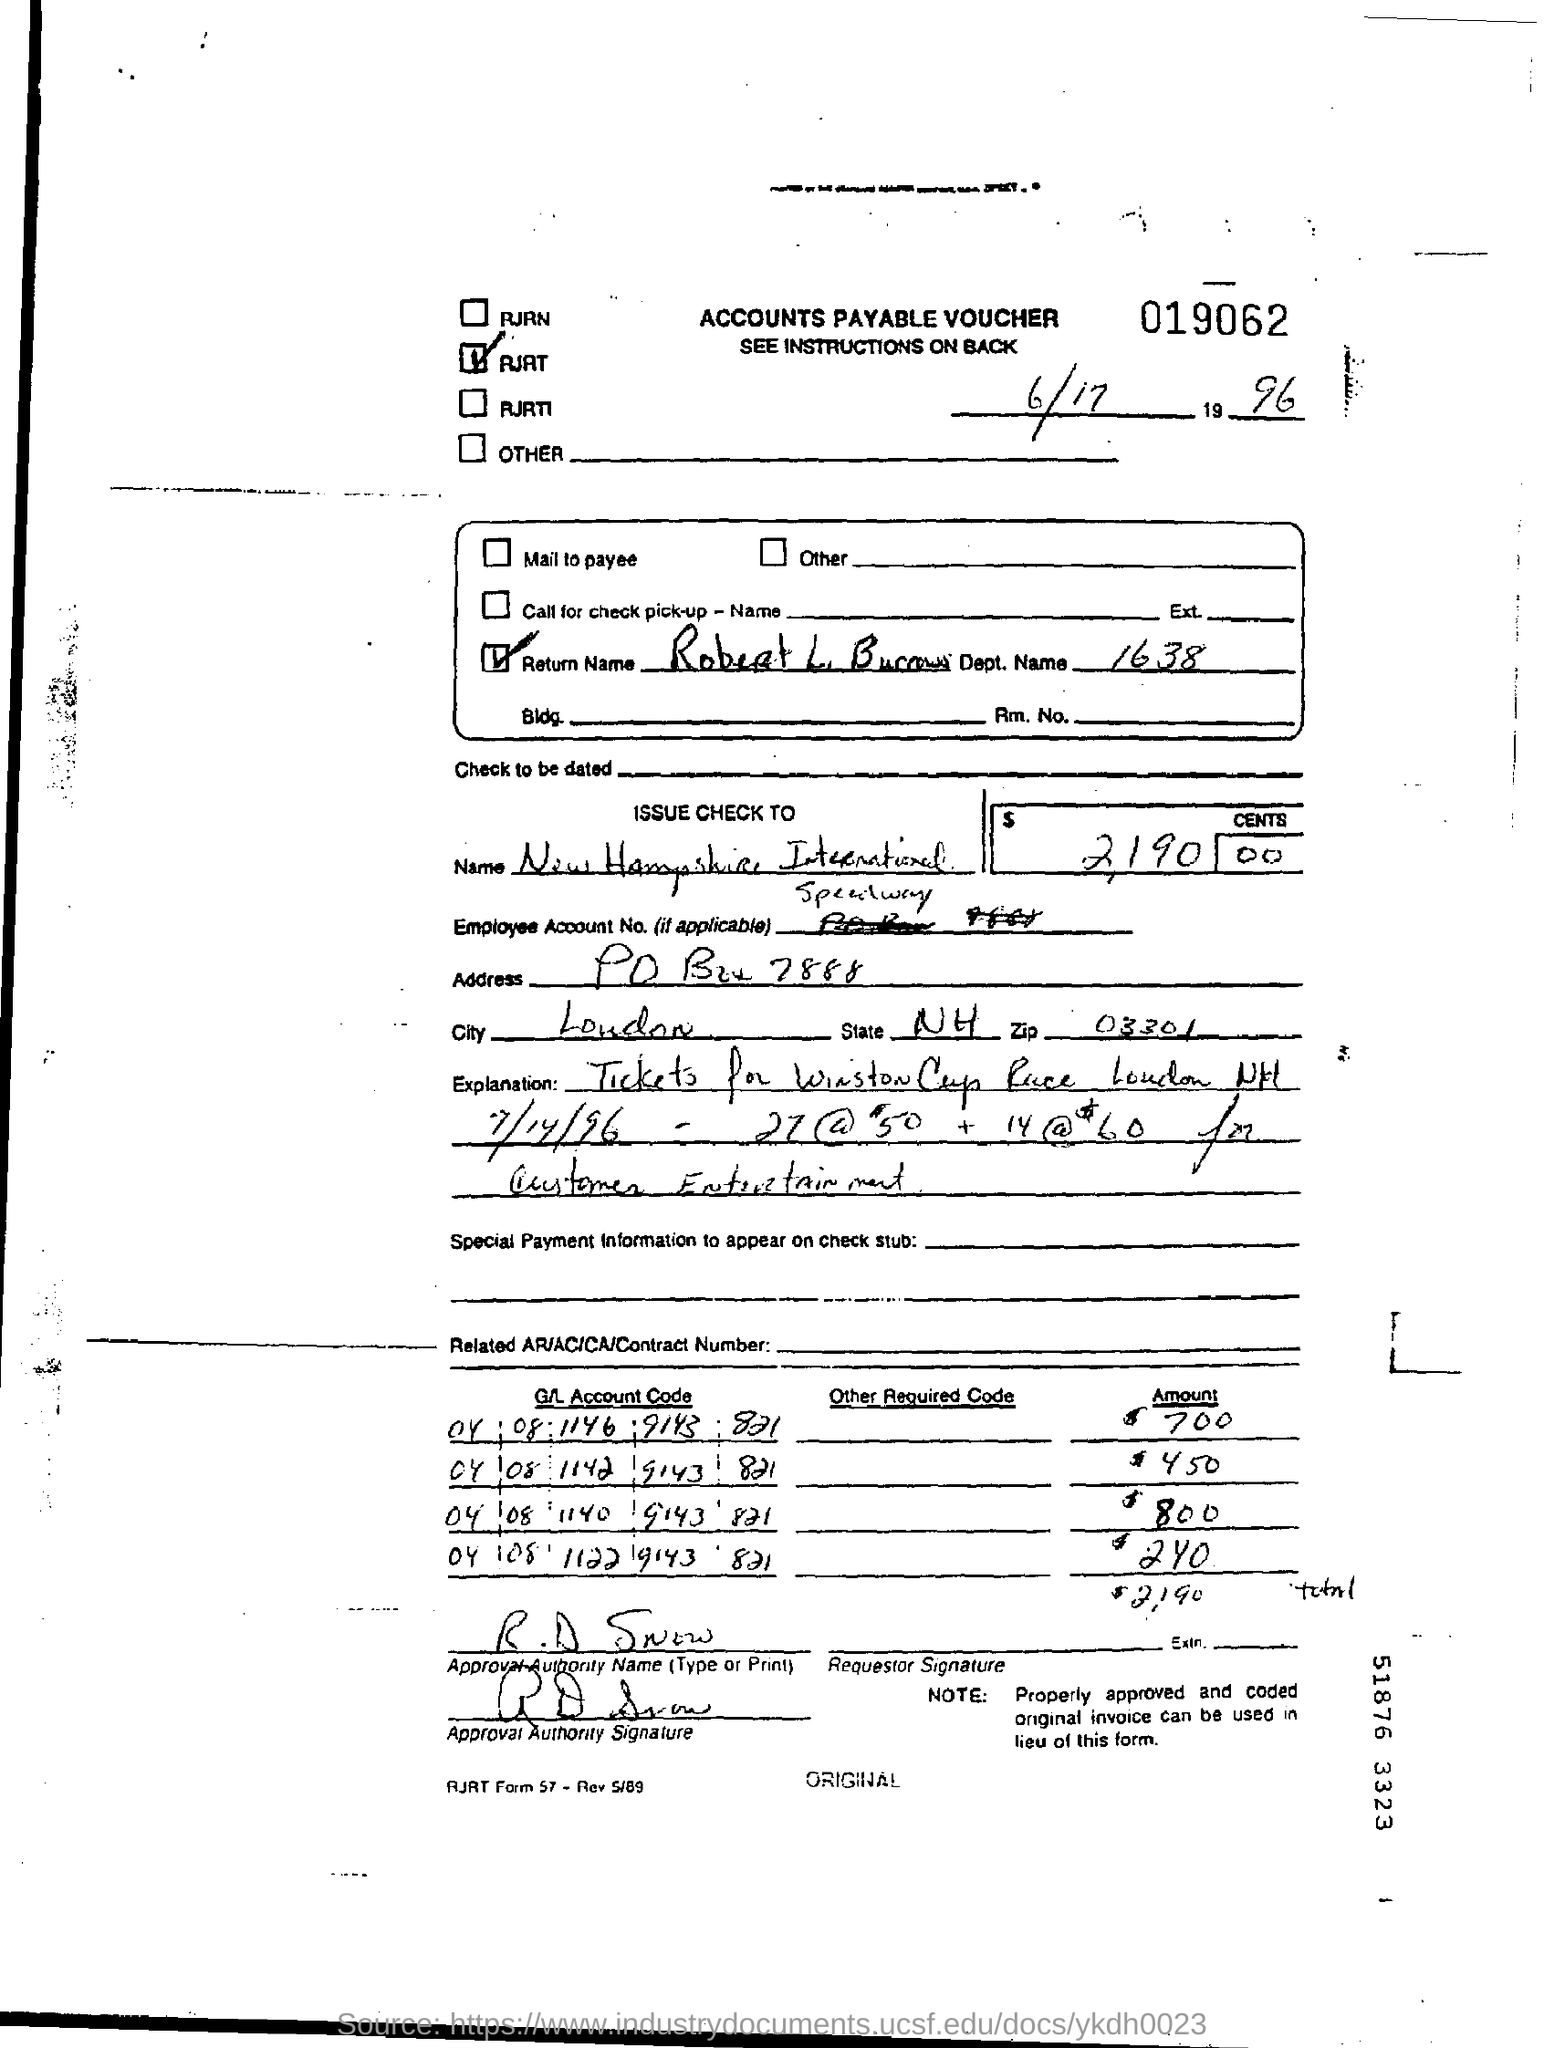What type of voucher is given here?
Your response must be concise. Accounts Payable Voucher. Who is the approval authority as per the voucher?
Keep it short and to the point. R .D Snow. What is the zip code no given in the address?
Your answer should be very brief. 03301. In whose name, the check is issued?
Provide a succinct answer. New Hampshire International. 